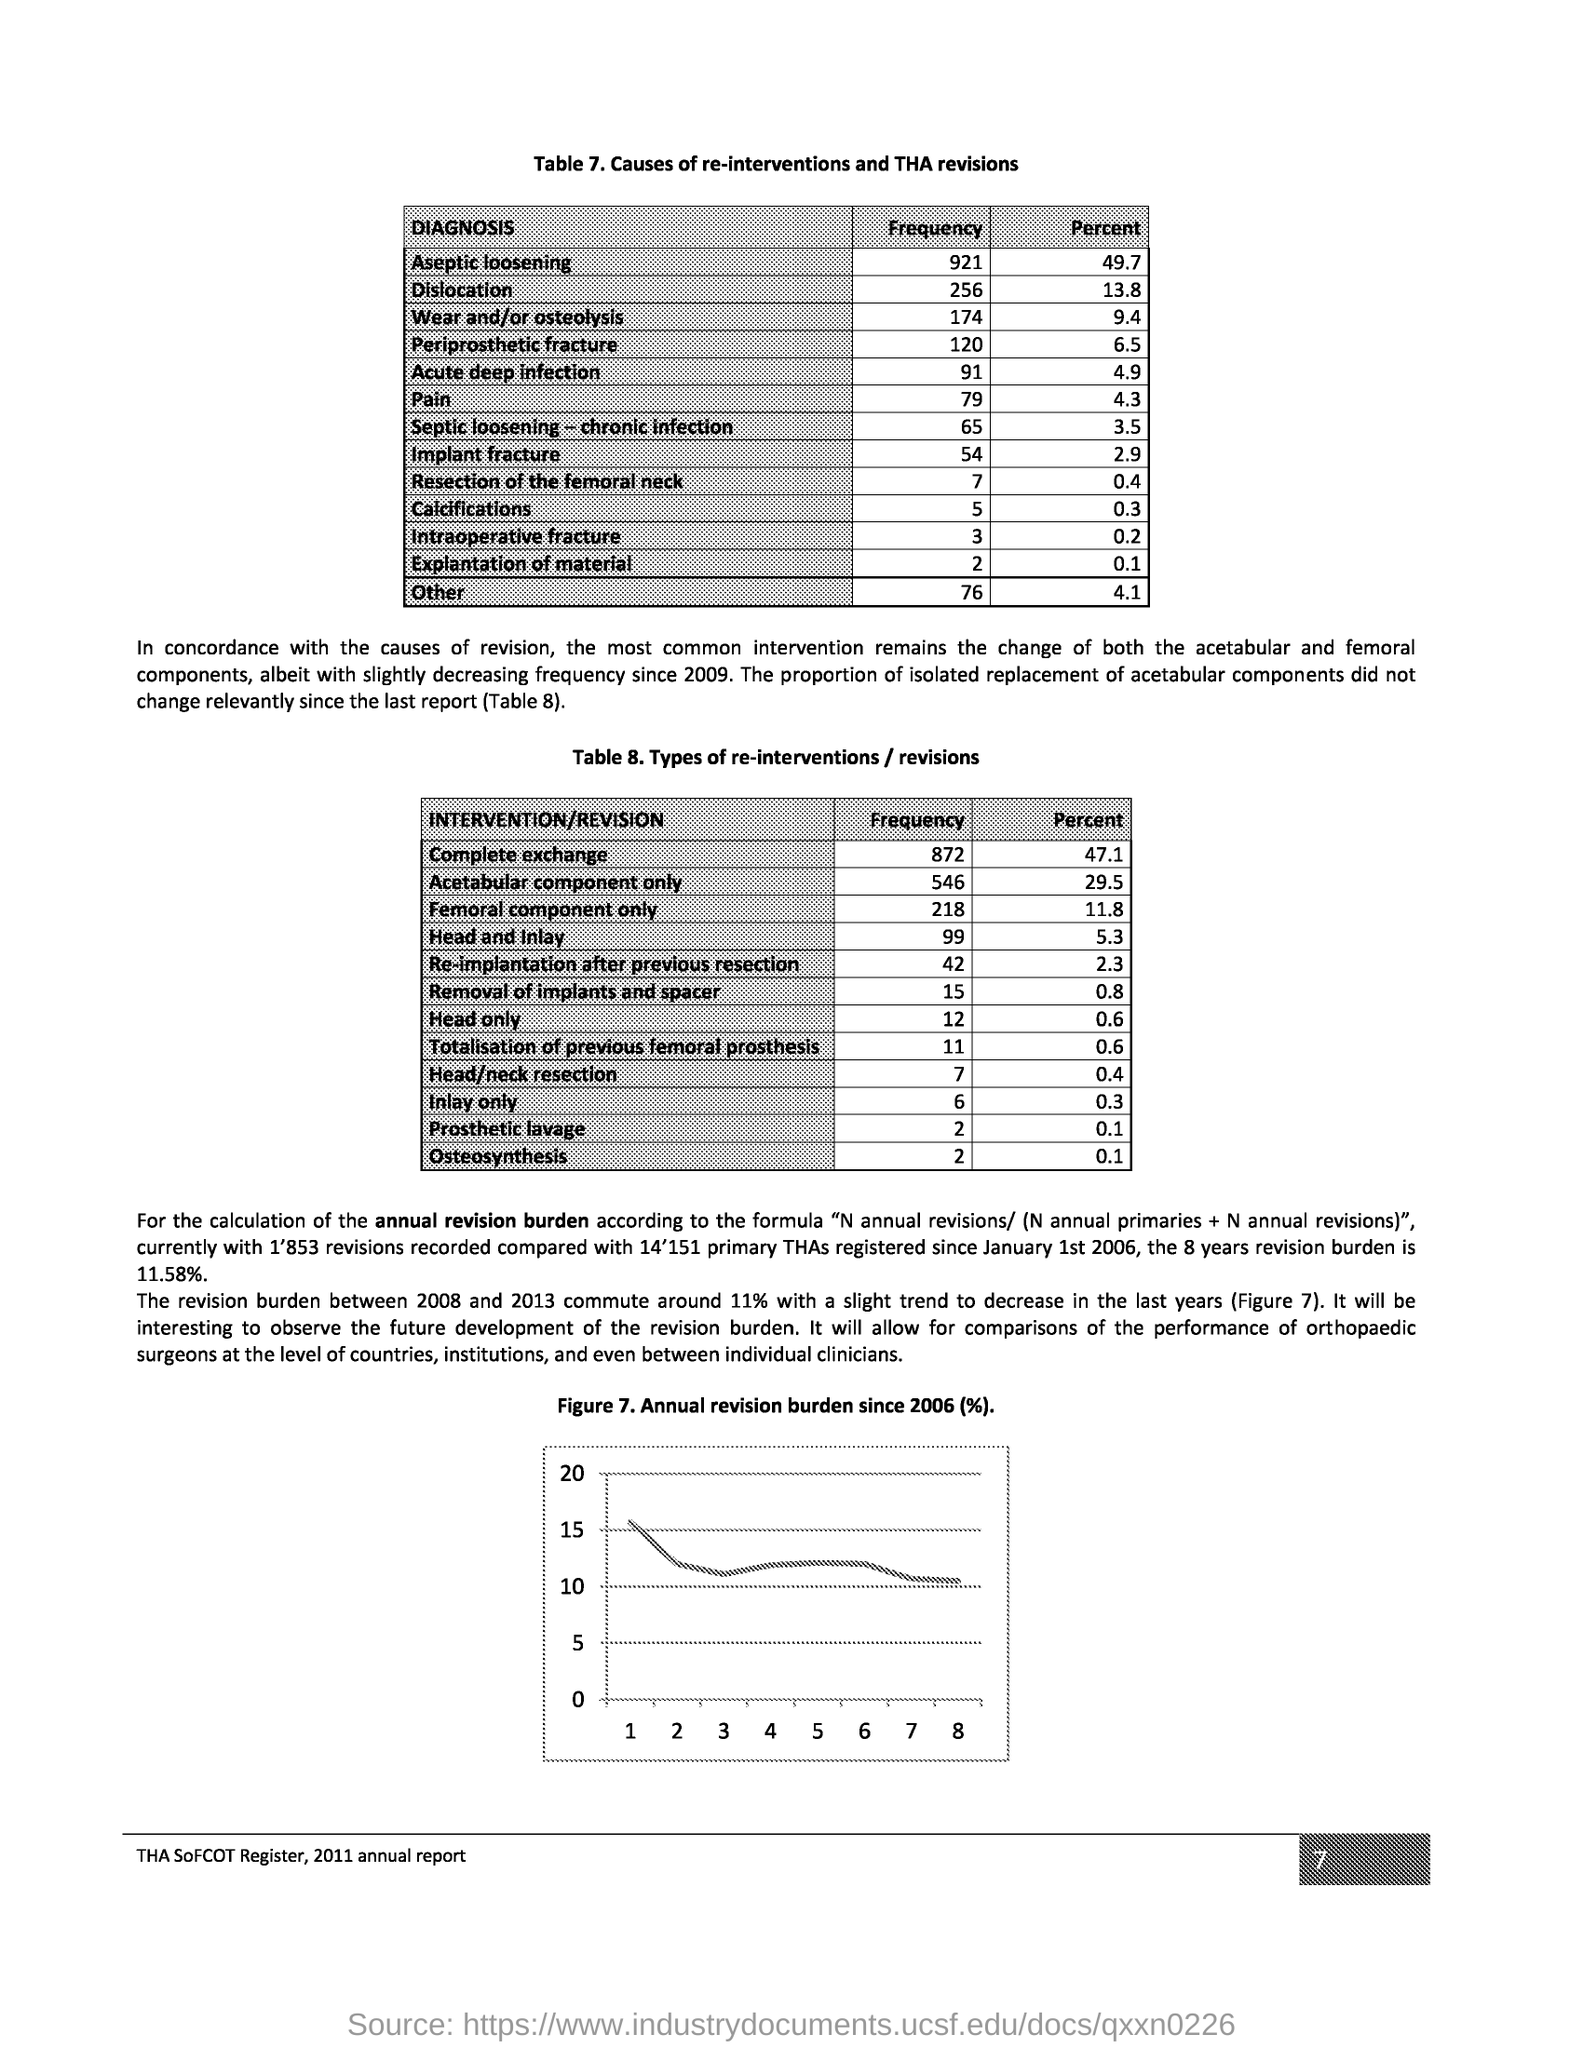Point out several critical features in this image. The page number is 7. 